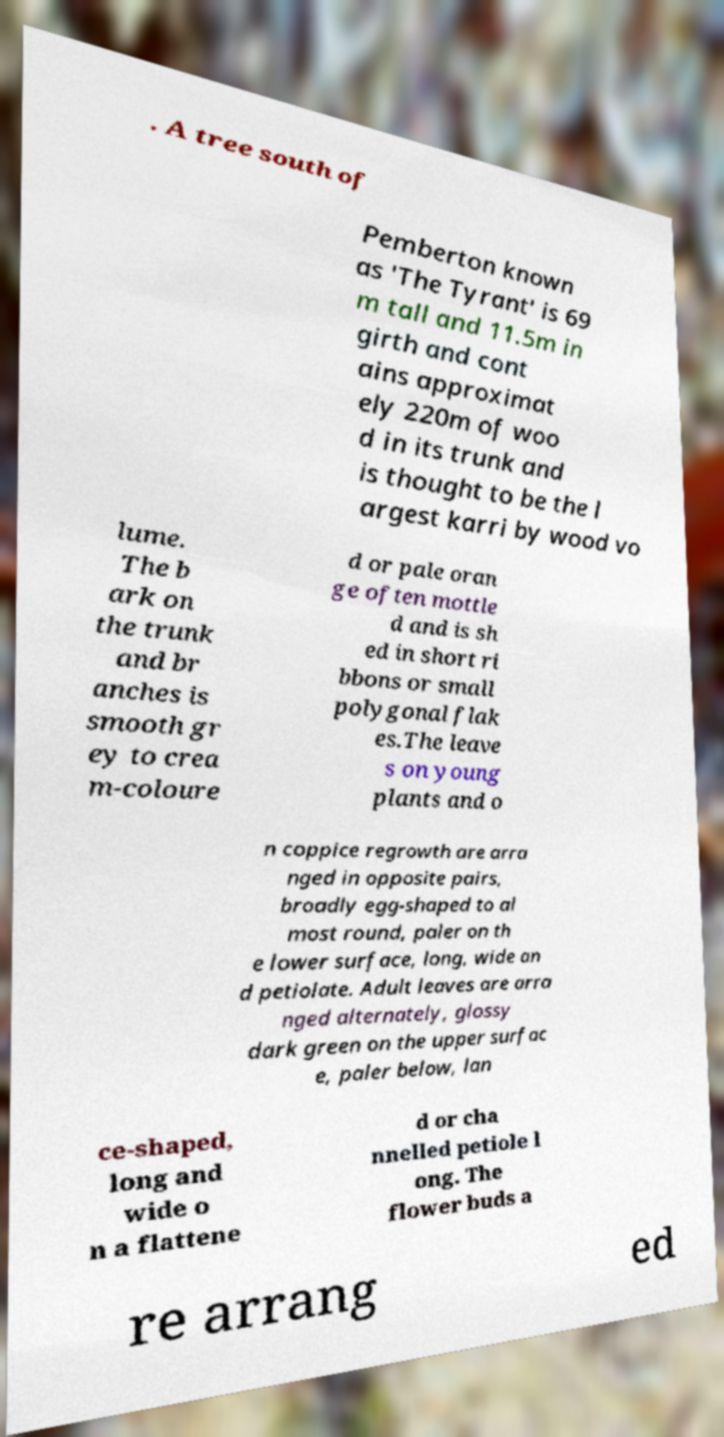Can you read and provide the text displayed in the image?This photo seems to have some interesting text. Can you extract and type it out for me? . A tree south of Pemberton known as 'The Tyrant' is 69 m tall and 11.5m in girth and cont ains approximat ely 220m of woo d in its trunk and is thought to be the l argest karri by wood vo lume. The b ark on the trunk and br anches is smooth gr ey to crea m-coloure d or pale oran ge often mottle d and is sh ed in short ri bbons or small polygonal flak es.The leave s on young plants and o n coppice regrowth are arra nged in opposite pairs, broadly egg-shaped to al most round, paler on th e lower surface, long, wide an d petiolate. Adult leaves are arra nged alternately, glossy dark green on the upper surfac e, paler below, lan ce-shaped, long and wide o n a flattene d or cha nnelled petiole l ong. The flower buds a re arrang ed 